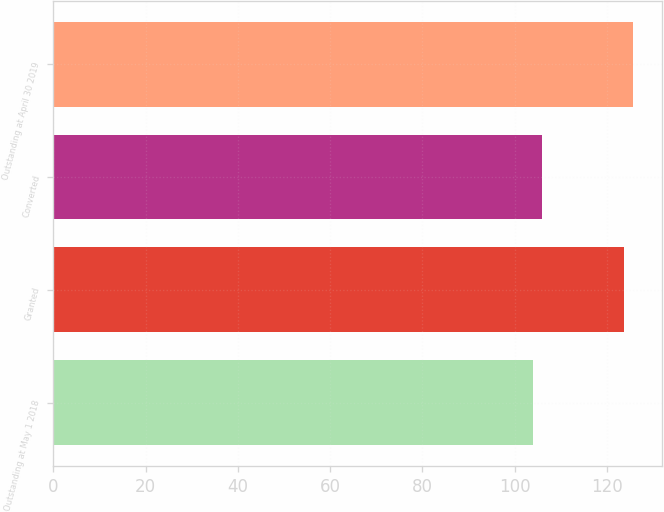Convert chart to OTSL. <chart><loc_0><loc_0><loc_500><loc_500><bar_chart><fcel>Outstanding at May 1 2018<fcel>Granted<fcel>Converted<fcel>Outstanding at April 30 2019<nl><fcel>103.86<fcel>123.68<fcel>105.84<fcel>125.66<nl></chart> 